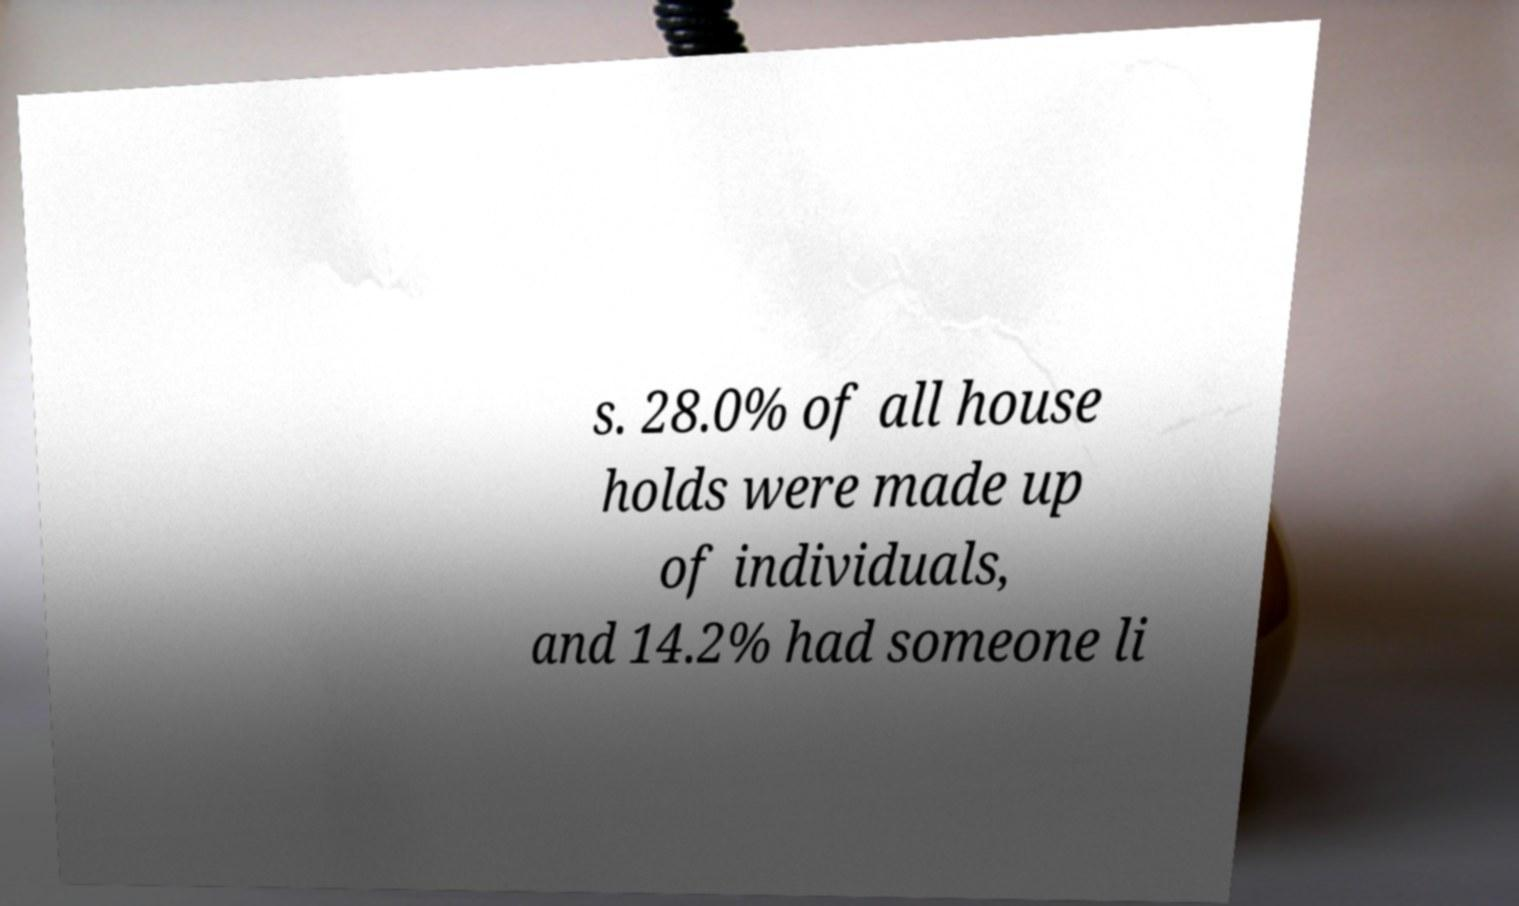Can you accurately transcribe the text from the provided image for me? s. 28.0% of all house holds were made up of individuals, and 14.2% had someone li 